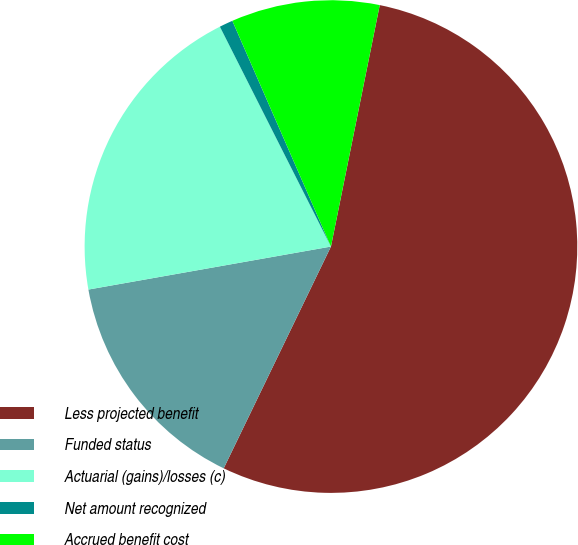<chart> <loc_0><loc_0><loc_500><loc_500><pie_chart><fcel>Less projected benefit<fcel>Funded status<fcel>Actuarial (gains)/losses (c)<fcel>Net amount recognized<fcel>Accrued benefit cost<nl><fcel>54.0%<fcel>15.04%<fcel>20.35%<fcel>0.89%<fcel>9.73%<nl></chart> 